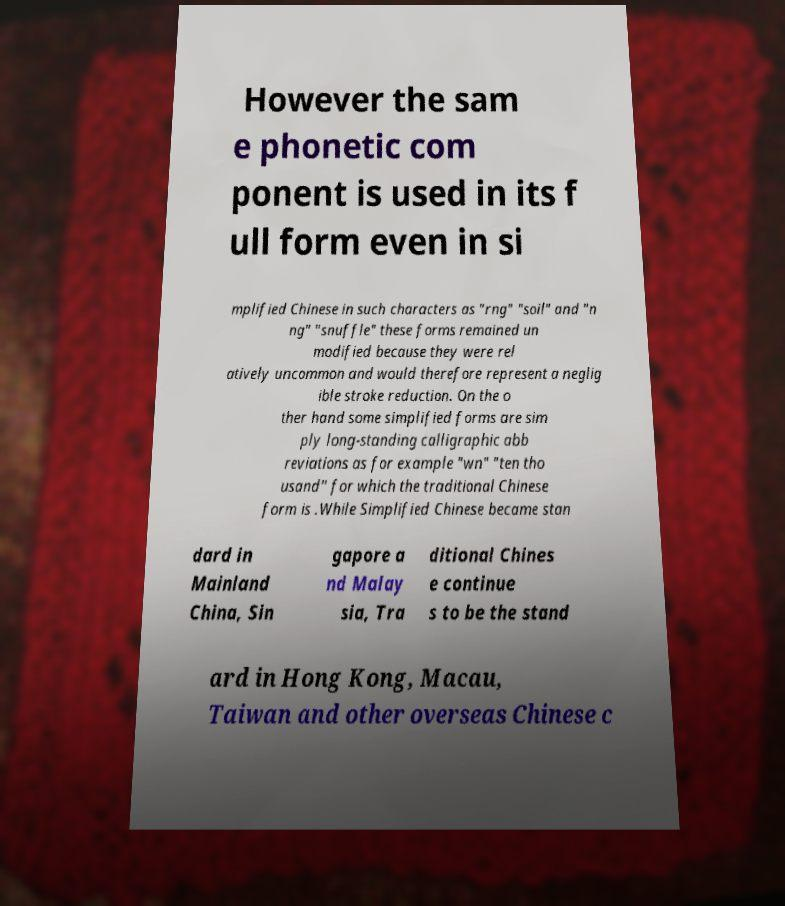What messages or text are displayed in this image? I need them in a readable, typed format. However the sam e phonetic com ponent is used in its f ull form even in si mplified Chinese in such characters as "rng" "soil" and "n ng" "snuffle" these forms remained un modified because they were rel atively uncommon and would therefore represent a neglig ible stroke reduction. On the o ther hand some simplified forms are sim ply long-standing calligraphic abb reviations as for example "wn" "ten tho usand" for which the traditional Chinese form is .While Simplified Chinese became stan dard in Mainland China, Sin gapore a nd Malay sia, Tra ditional Chines e continue s to be the stand ard in Hong Kong, Macau, Taiwan and other overseas Chinese c 